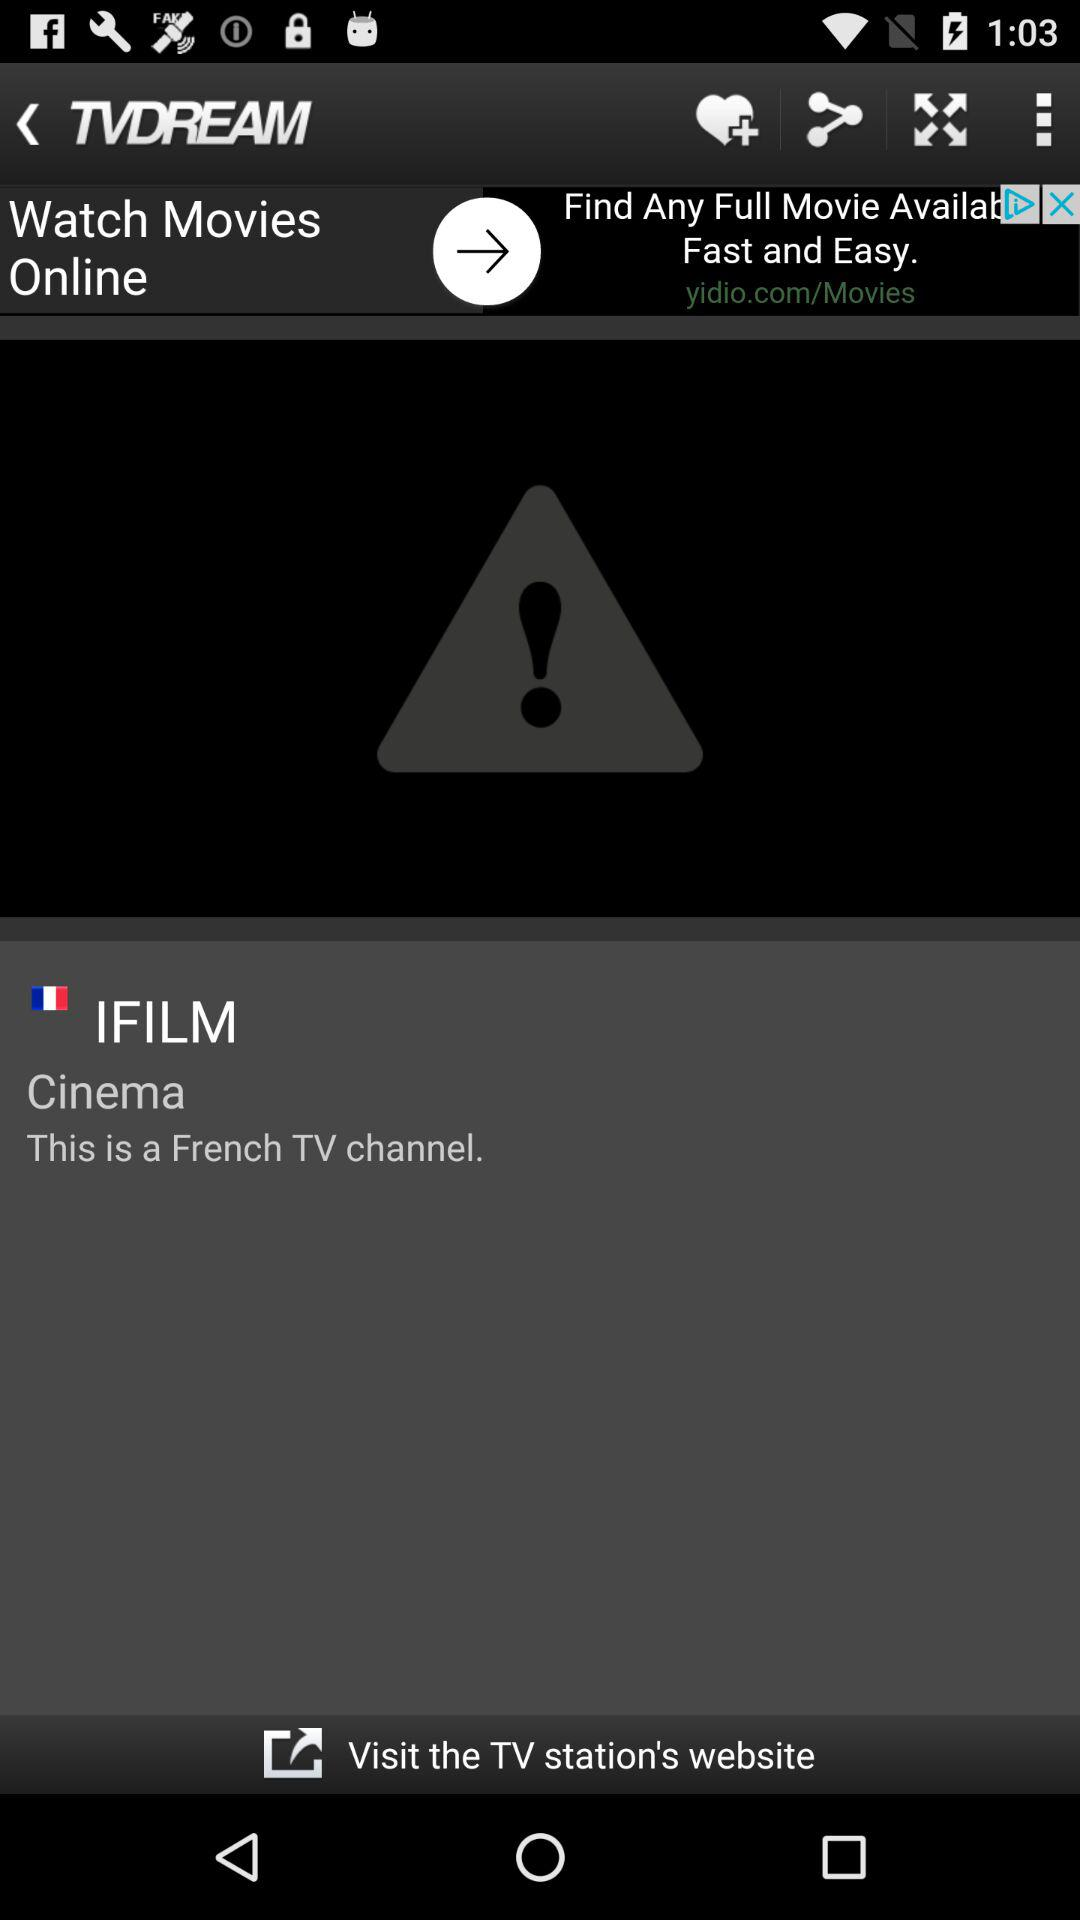What is the application name? The application name is "TVDREAM". 